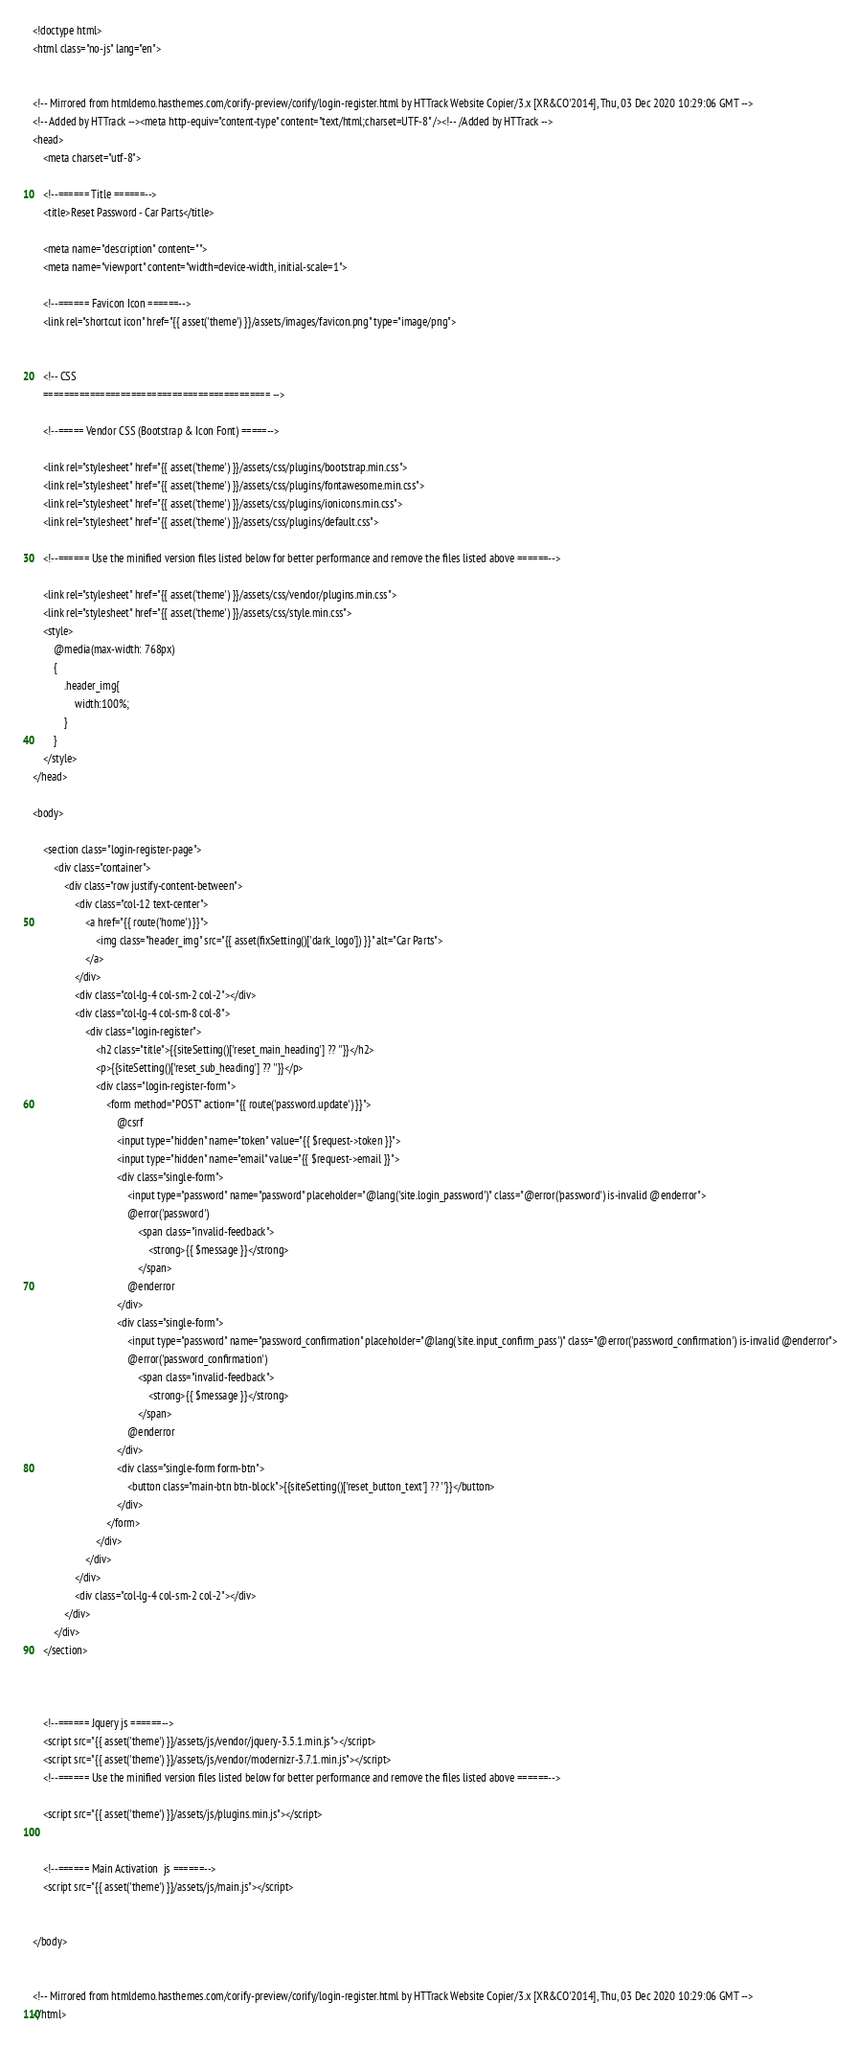<code> <loc_0><loc_0><loc_500><loc_500><_PHP_><!doctype html>
<html class="no-js" lang="en">


<!-- Mirrored from htmldemo.hasthemes.com/corify-preview/corify/login-register.html by HTTrack Website Copier/3.x [XR&CO'2014], Thu, 03 Dec 2020 10:29:06 GMT -->
<!-- Added by HTTrack --><meta http-equiv="content-type" content="text/html;charset=UTF-8" /><!-- /Added by HTTrack -->
<head>
    <meta charset="utf-8">

    <!--====== Title ======-->
    <title>Reset Password - Car Parts</title>

    <meta name="description" content="">
    <meta name="viewport" content="width=device-width, initial-scale=1">

    <!--====== Favicon Icon ======-->
    <link rel="shortcut icon" href="{{ asset('theme') }}/assets/images/favicon.png" type="image/png">


    <!-- CSS
    ============================================ -->

    <!--===== Vendor CSS (Bootstrap & Icon Font) =====-->

    <link rel="stylesheet" href="{{ asset('theme') }}/assets/css/plugins/bootstrap.min.css">
    <link rel="stylesheet" href="{{ asset('theme') }}/assets/css/plugins/fontawesome.min.css">
    <link rel="stylesheet" href="{{ asset('theme') }}/assets/css/plugins/ionicons.min.css">
    <link rel="stylesheet" href="{{ asset('theme') }}/assets/css/plugins/default.css">

    <!--====== Use the minified version files listed below for better performance and remove the files listed above ======-->

    <link rel="stylesheet" href="{{ asset('theme') }}/assets/css/vendor/plugins.min.css">
    <link rel="stylesheet" href="{{ asset('theme') }}/assets/css/style.min.css">
    <style>
        @media(max-width: 768px)
        {
            .header_img{
                width:100%;
            }
        }
    </style>
</head>

<body>

    <section class="login-register-page">
        <div class="container">
            <div class="row justify-content-between">
                <div class="col-12 text-center">
                    <a href="{{ route('home') }}">
                        <img class="header_img" src="{{ asset(fixSetting()['dark_logo']) }}" alt="Car Parts">
                    </a>
                </div>
                <div class="col-lg-4 col-sm-2 col-2"></div>
                <div class="col-lg-4 col-sm-8 col-8">
                    <div class="login-register">
                        <h2 class="title">{{siteSetting()['reset_main_heading'] ?? ''}}</h2>
                        <p>{{siteSetting()['reset_sub_heading'] ?? ''}}</p>
                        <div class="login-register-form">
                            <form method="POST" action="{{ route('password.update') }}">
                                @csrf
                                <input type="hidden" name="token" value="{{ $request->token }}">
                                <input type="hidden" name="email" value="{{ $request->email }}">
                                <div class="single-form">
                                    <input type="password" name="password" placeholder="@lang('site.login_password')" class="@error('password') is-invalid @enderror">
                                    @error('password')
                                        <span class="invalid-feedback">
                                            <strong>{{ $message }}</strong>
                                        </span>
                                    @enderror
                                </div>
                                <div class="single-form">
                                    <input type="password" name="password_confirmation" placeholder="@lang('site.input_confirm_pass')" class="@error('password_confirmation') is-invalid @enderror">
                                    @error('password_confirmation')
                                        <span class="invalid-feedback">
                                            <strong>{{ $message }}</strong>
                                        </span>
                                    @enderror
                                </div>
                                <div class="single-form form-btn">
                                    <button class="main-btn btn-block">{{siteSetting()['reset_button_text'] ?? ''}}</button>
                                </div>
                            </form>
                        </div>
                    </div>
                </div>
                <div class="col-lg-4 col-sm-2 col-2"></div>
            </div>
        </div>
    </section>



    <!--====== Jquery js ======-->
    <script src="{{ asset('theme') }}/assets/js/vendor/jquery-3.5.1.min.js"></script>
    <script src="{{ asset('theme') }}/assets/js/vendor/modernizr-3.7.1.min.js"></script>
    <!--====== Use the minified version files listed below for better performance and remove the files listed above ======-->

    <script src="{{ asset('theme') }}/assets/js/plugins.min.js"></script>


    <!--====== Main Activation  js ======-->
    <script src="{{ asset('theme') }}/assets/js/main.js"></script>


</body>


<!-- Mirrored from htmldemo.hasthemes.com/corify-preview/corify/login-register.html by HTTrack Website Copier/3.x [XR&CO'2014], Thu, 03 Dec 2020 10:29:06 GMT -->
</html>
</code> 